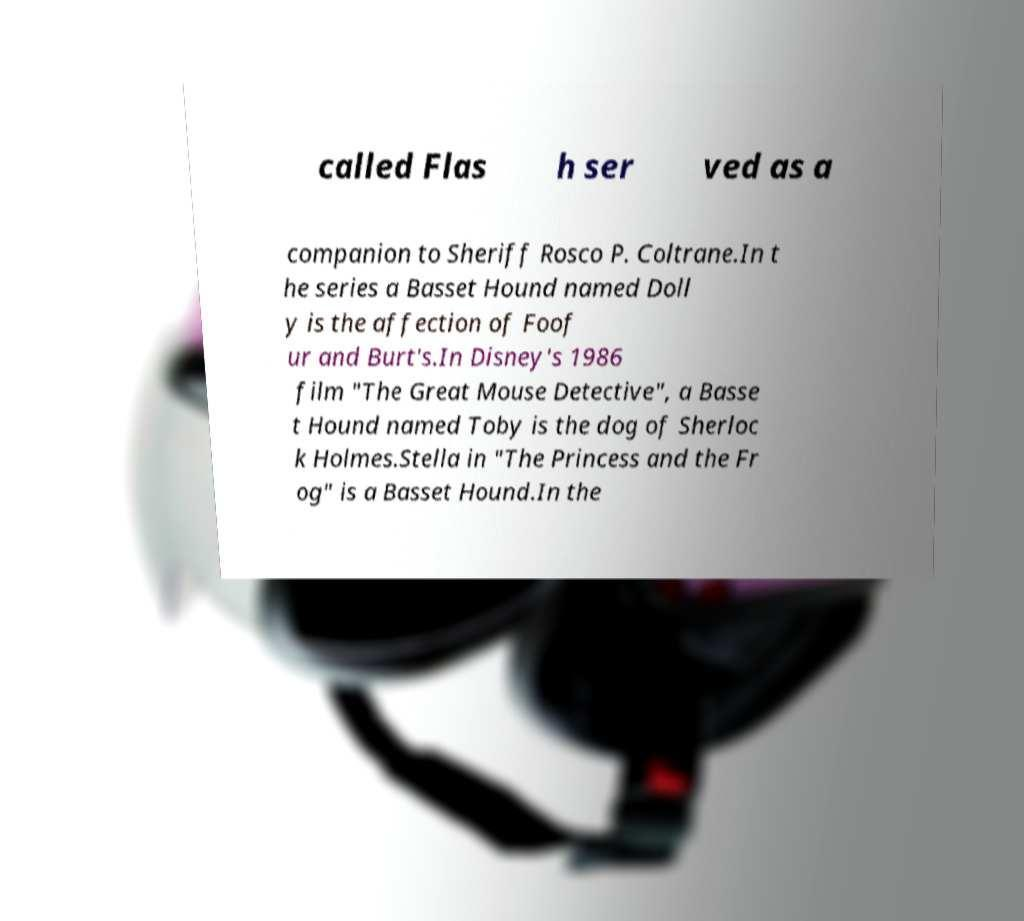Please read and relay the text visible in this image. What does it say? called Flas h ser ved as a companion to Sheriff Rosco P. Coltrane.In t he series a Basset Hound named Doll y is the affection of Foof ur and Burt's.In Disney's 1986 film "The Great Mouse Detective", a Basse t Hound named Toby is the dog of Sherloc k Holmes.Stella in "The Princess and the Fr og" is a Basset Hound.In the 